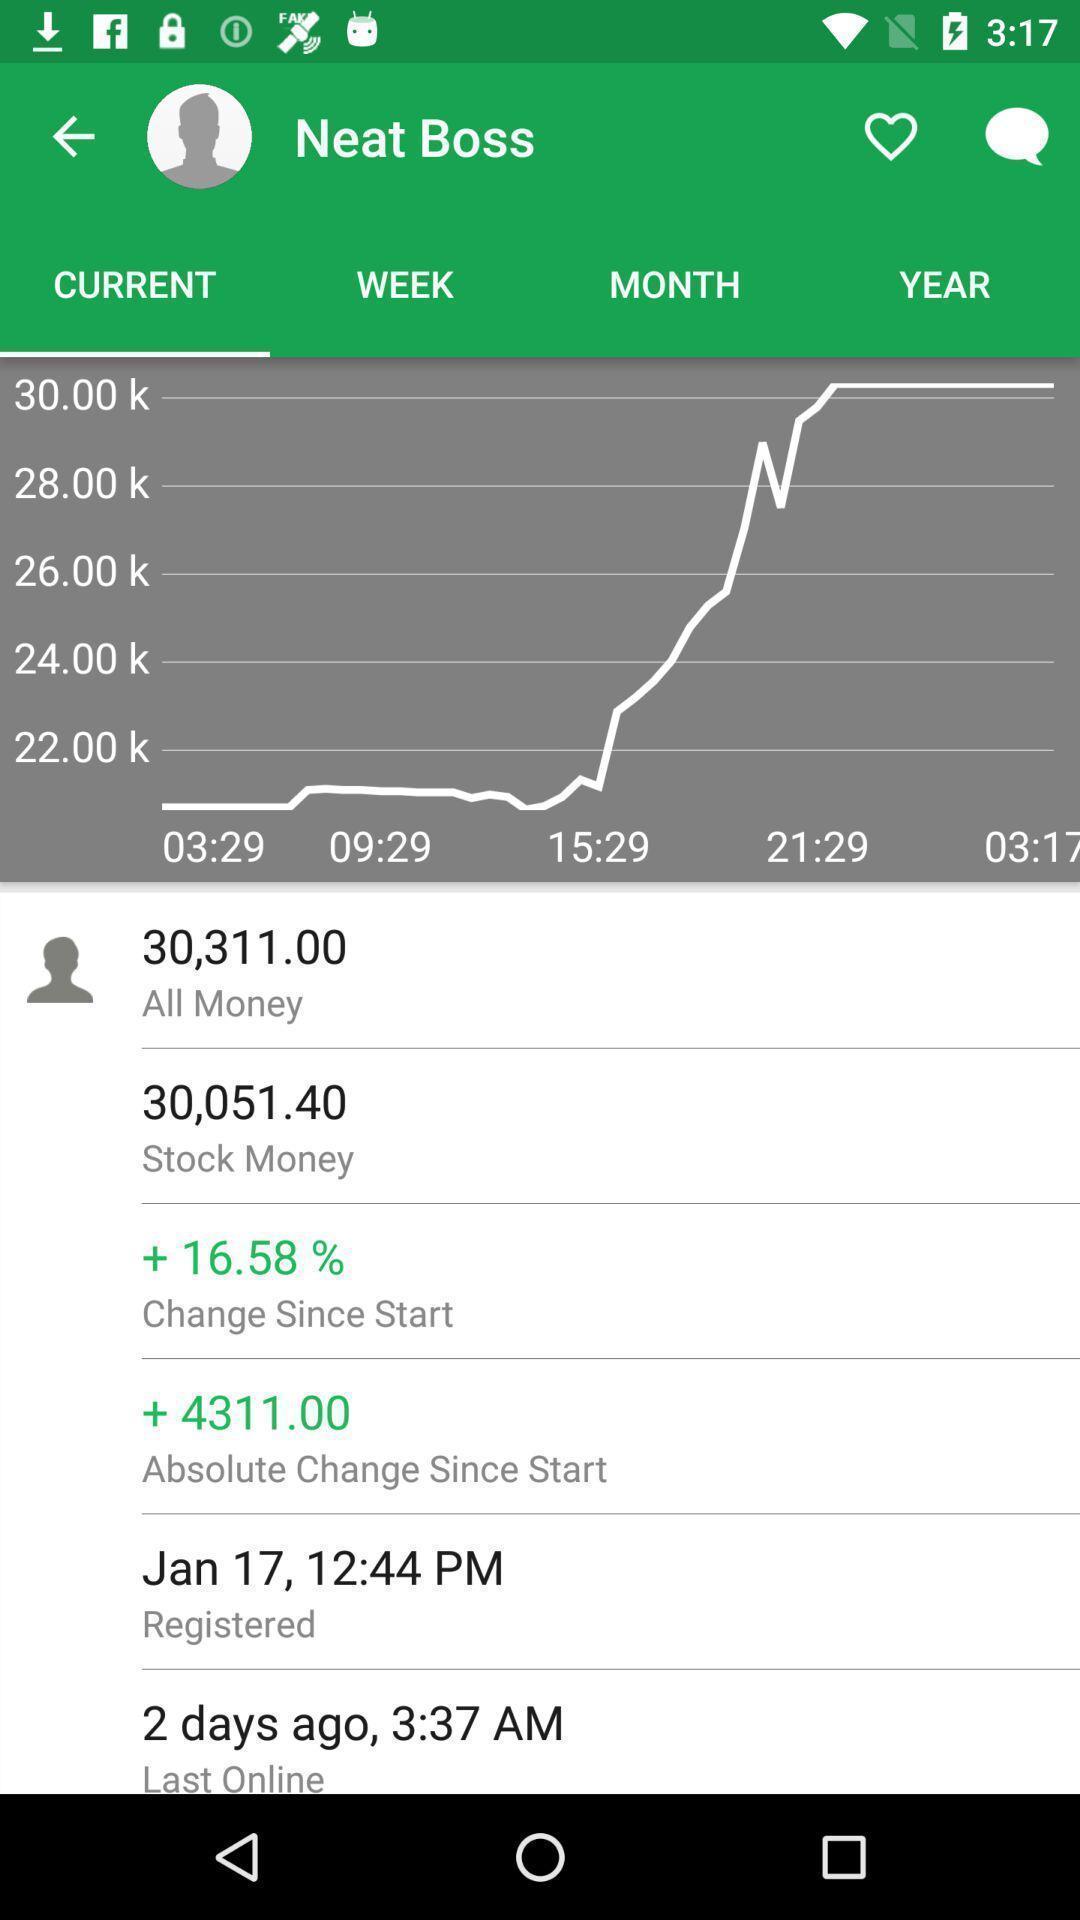Provide a textual representation of this image. Page showing current status in a trading app. 